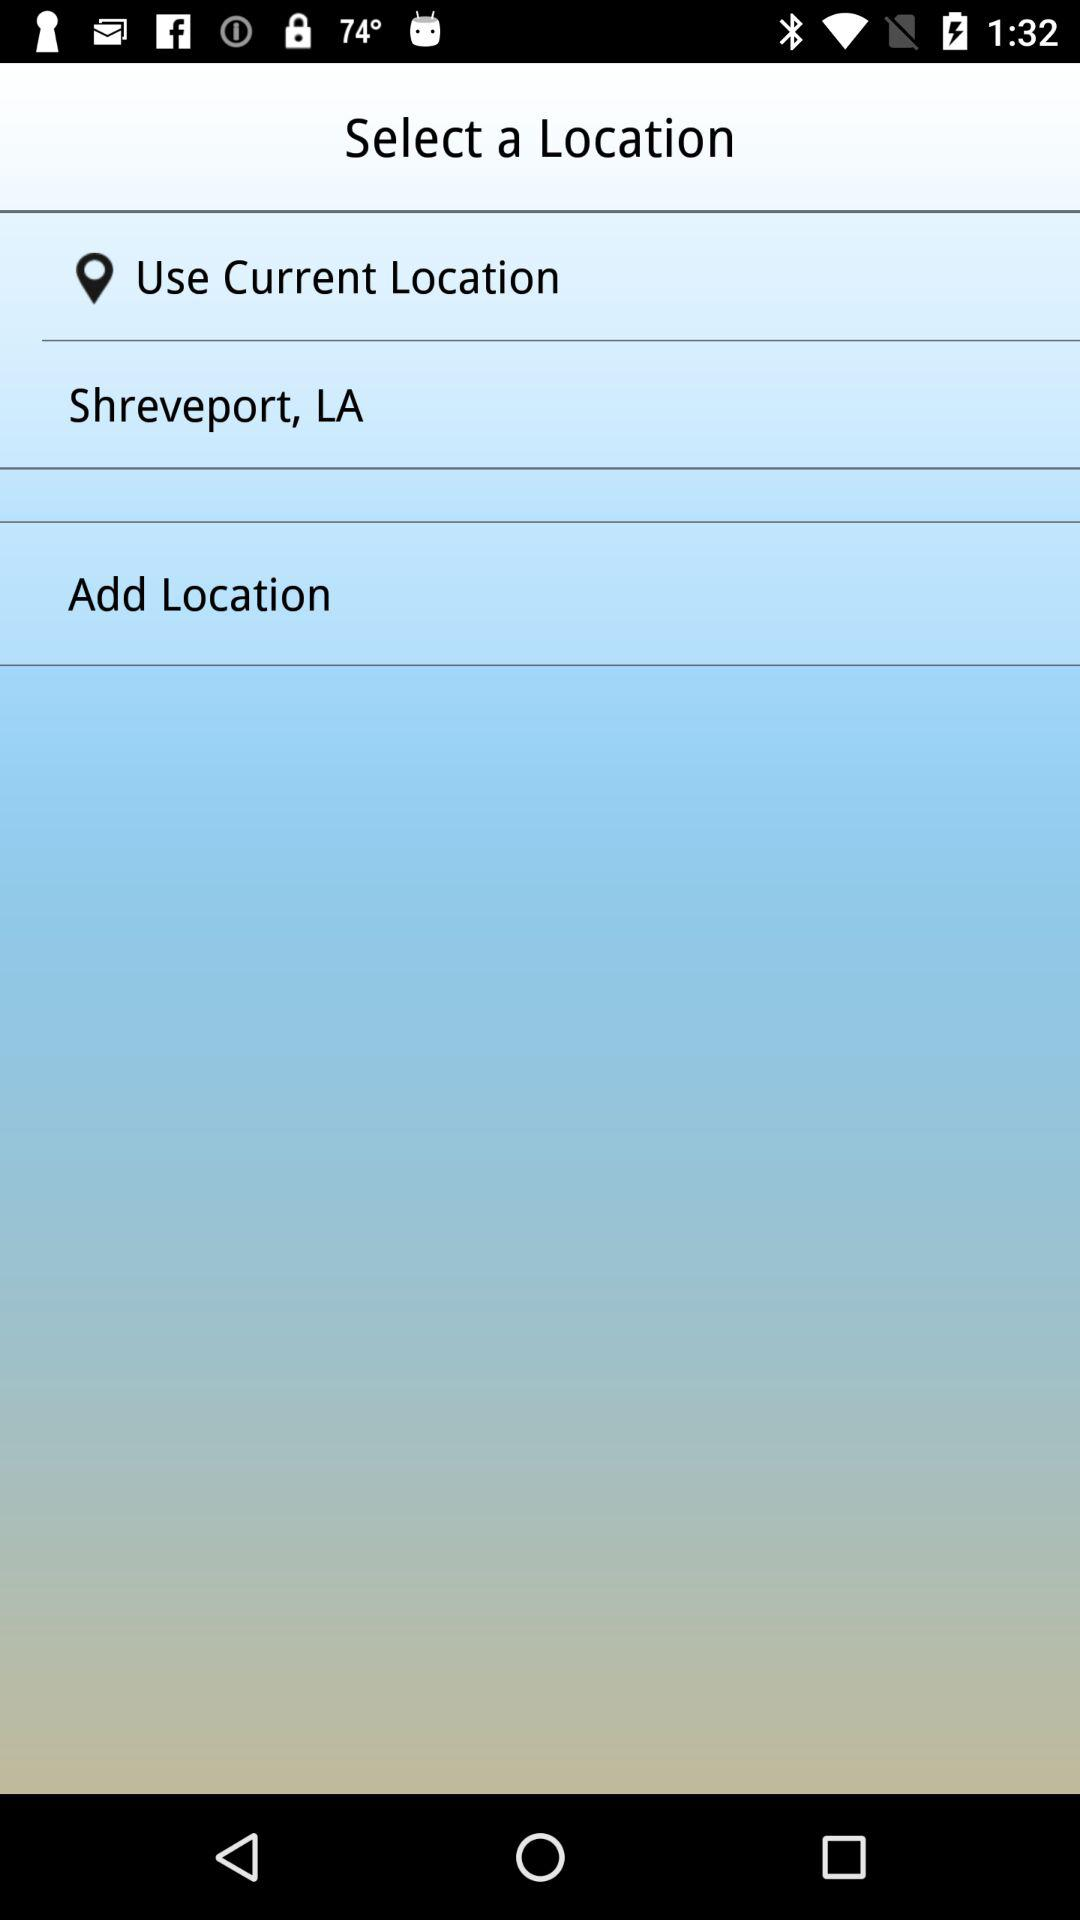What is the current location? The current location is Shreveport, LA. 